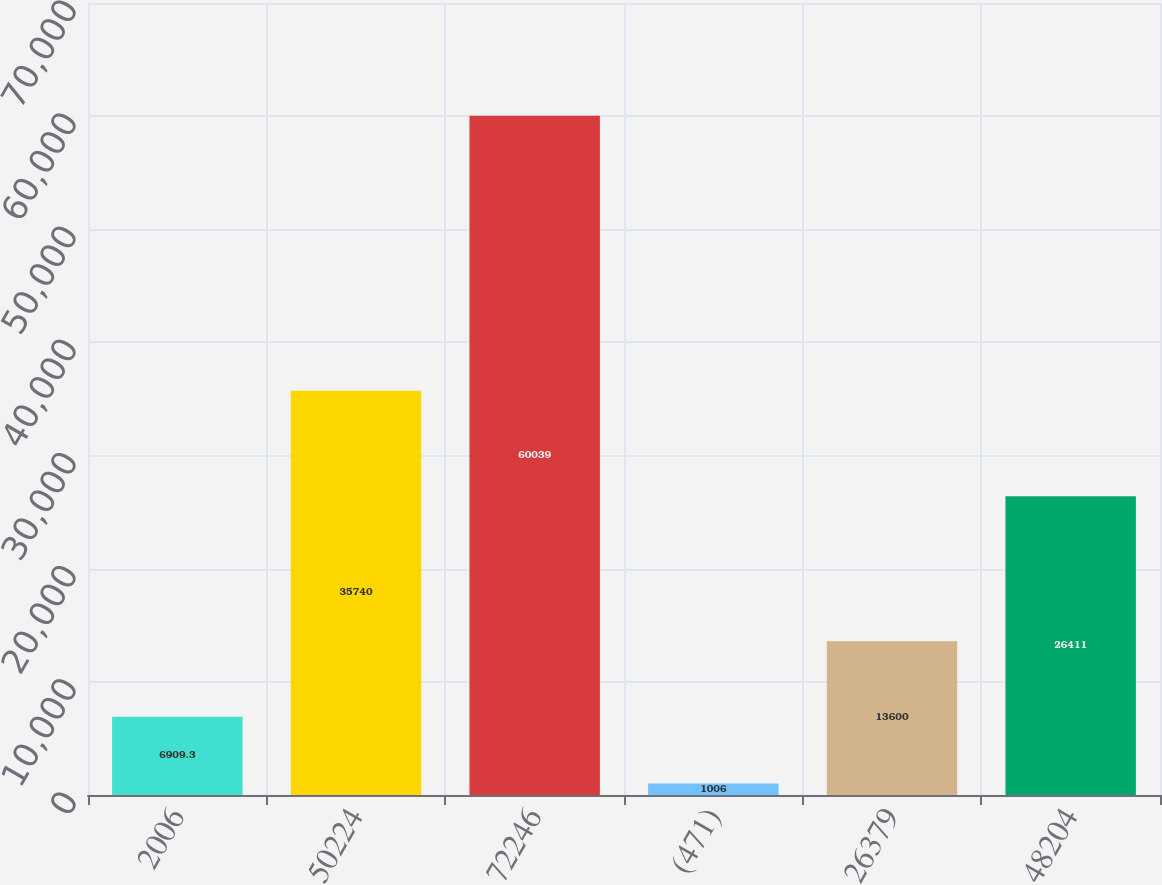<chart> <loc_0><loc_0><loc_500><loc_500><bar_chart><fcel>2006<fcel>50224<fcel>72246<fcel>(471)<fcel>26379<fcel>48204<nl><fcel>6909.3<fcel>35740<fcel>60039<fcel>1006<fcel>13600<fcel>26411<nl></chart> 